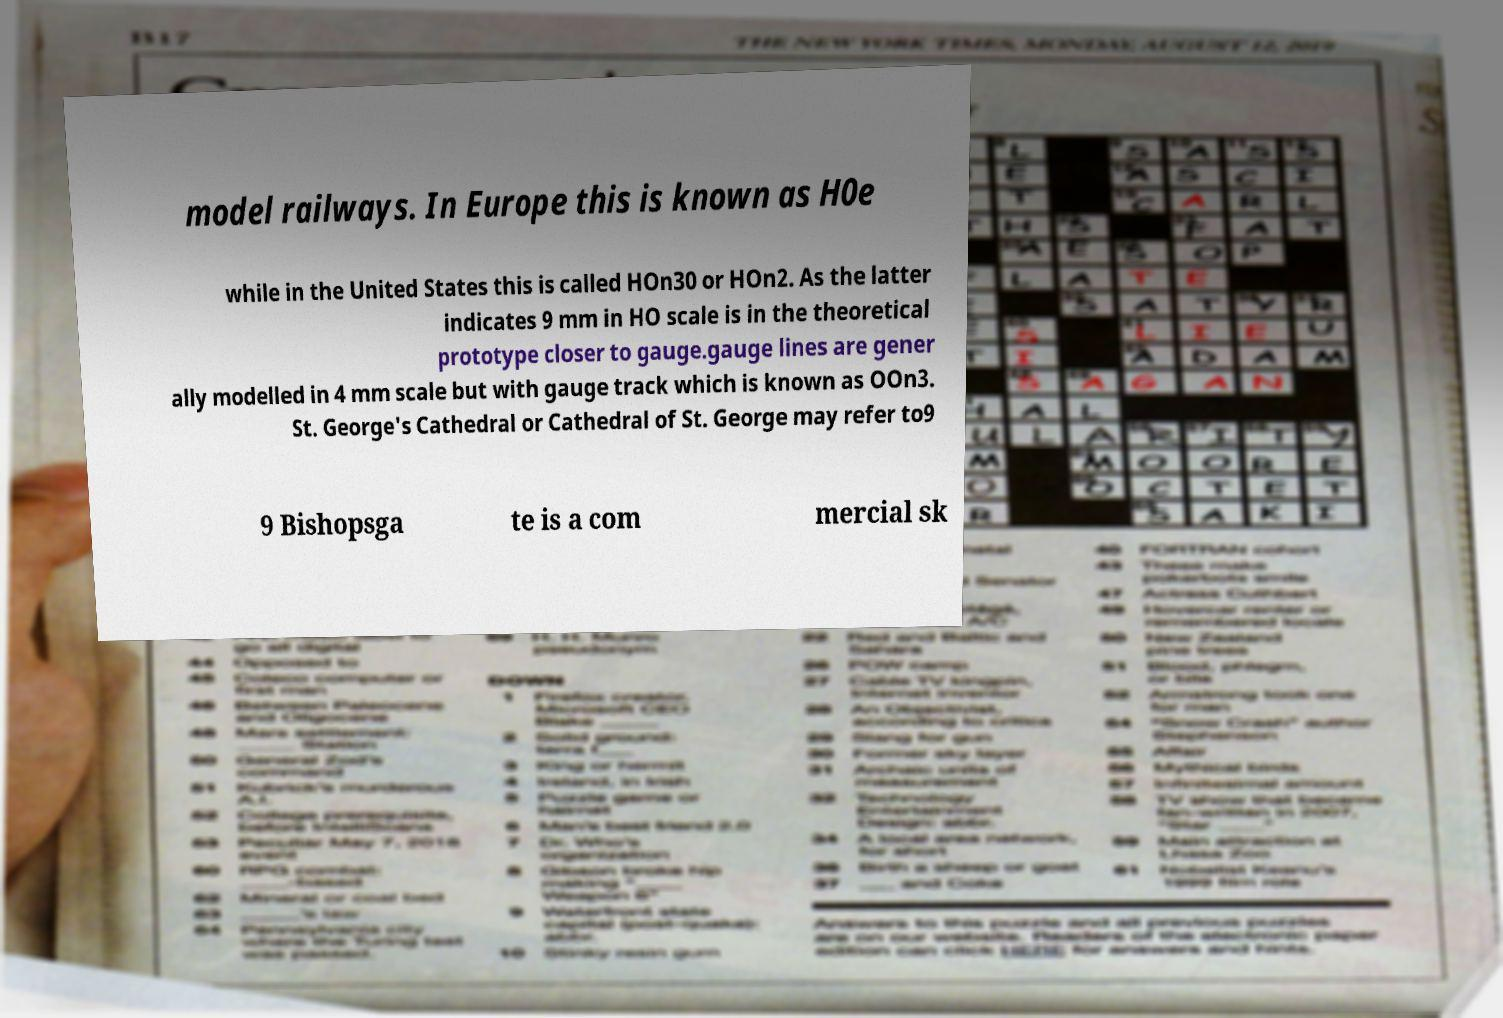There's text embedded in this image that I need extracted. Can you transcribe it verbatim? model railways. In Europe this is known as H0e while in the United States this is called HOn30 or HOn2. As the latter indicates 9 mm in HO scale is in the theoretical prototype closer to gauge.gauge lines are gener ally modelled in 4 mm scale but with gauge track which is known as OOn3. St. George's Cathedral or Cathedral of St. George may refer to9 9 Bishopsga te is a com mercial sk 